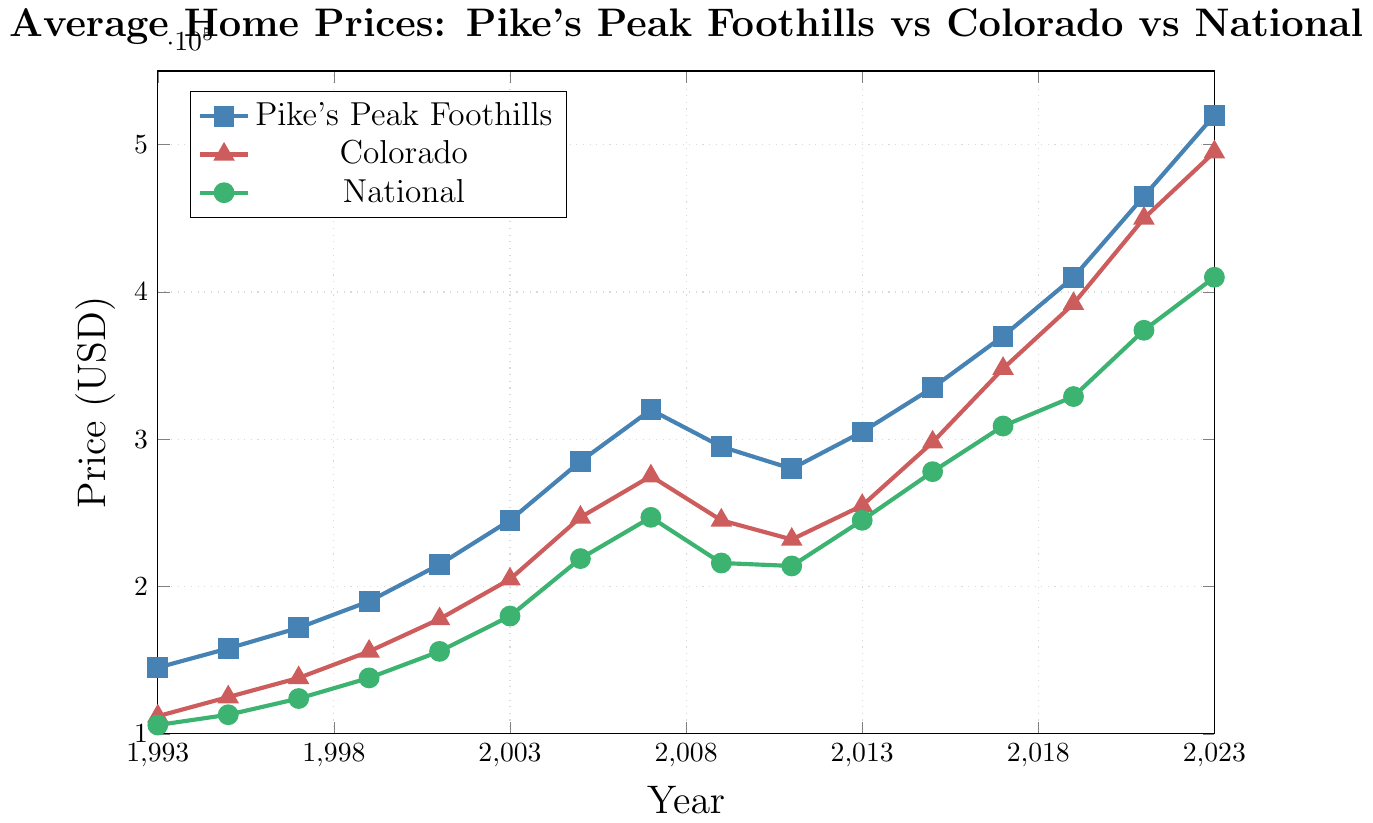In which year did the average home prices in Colorado surpass the national average for the first time? By comparing the lines for Colorado and the National average, we need to find the first point where the Colorado line crosses above the National line. This happens between 1999 and 2001, and looking at the exact points, 2001 is the first year where Colorado's average price of 178000 surpasses the National average price of 156000.
Answer: 2001 Which region had the highest average home prices consistently over the entire period? By observing the three lines in the plot, the line for Pike's Peak Foothills stays above the other two most of the time. It consistently has the highest values throughout the entire period.
Answer: Pike's Peak Foothills 